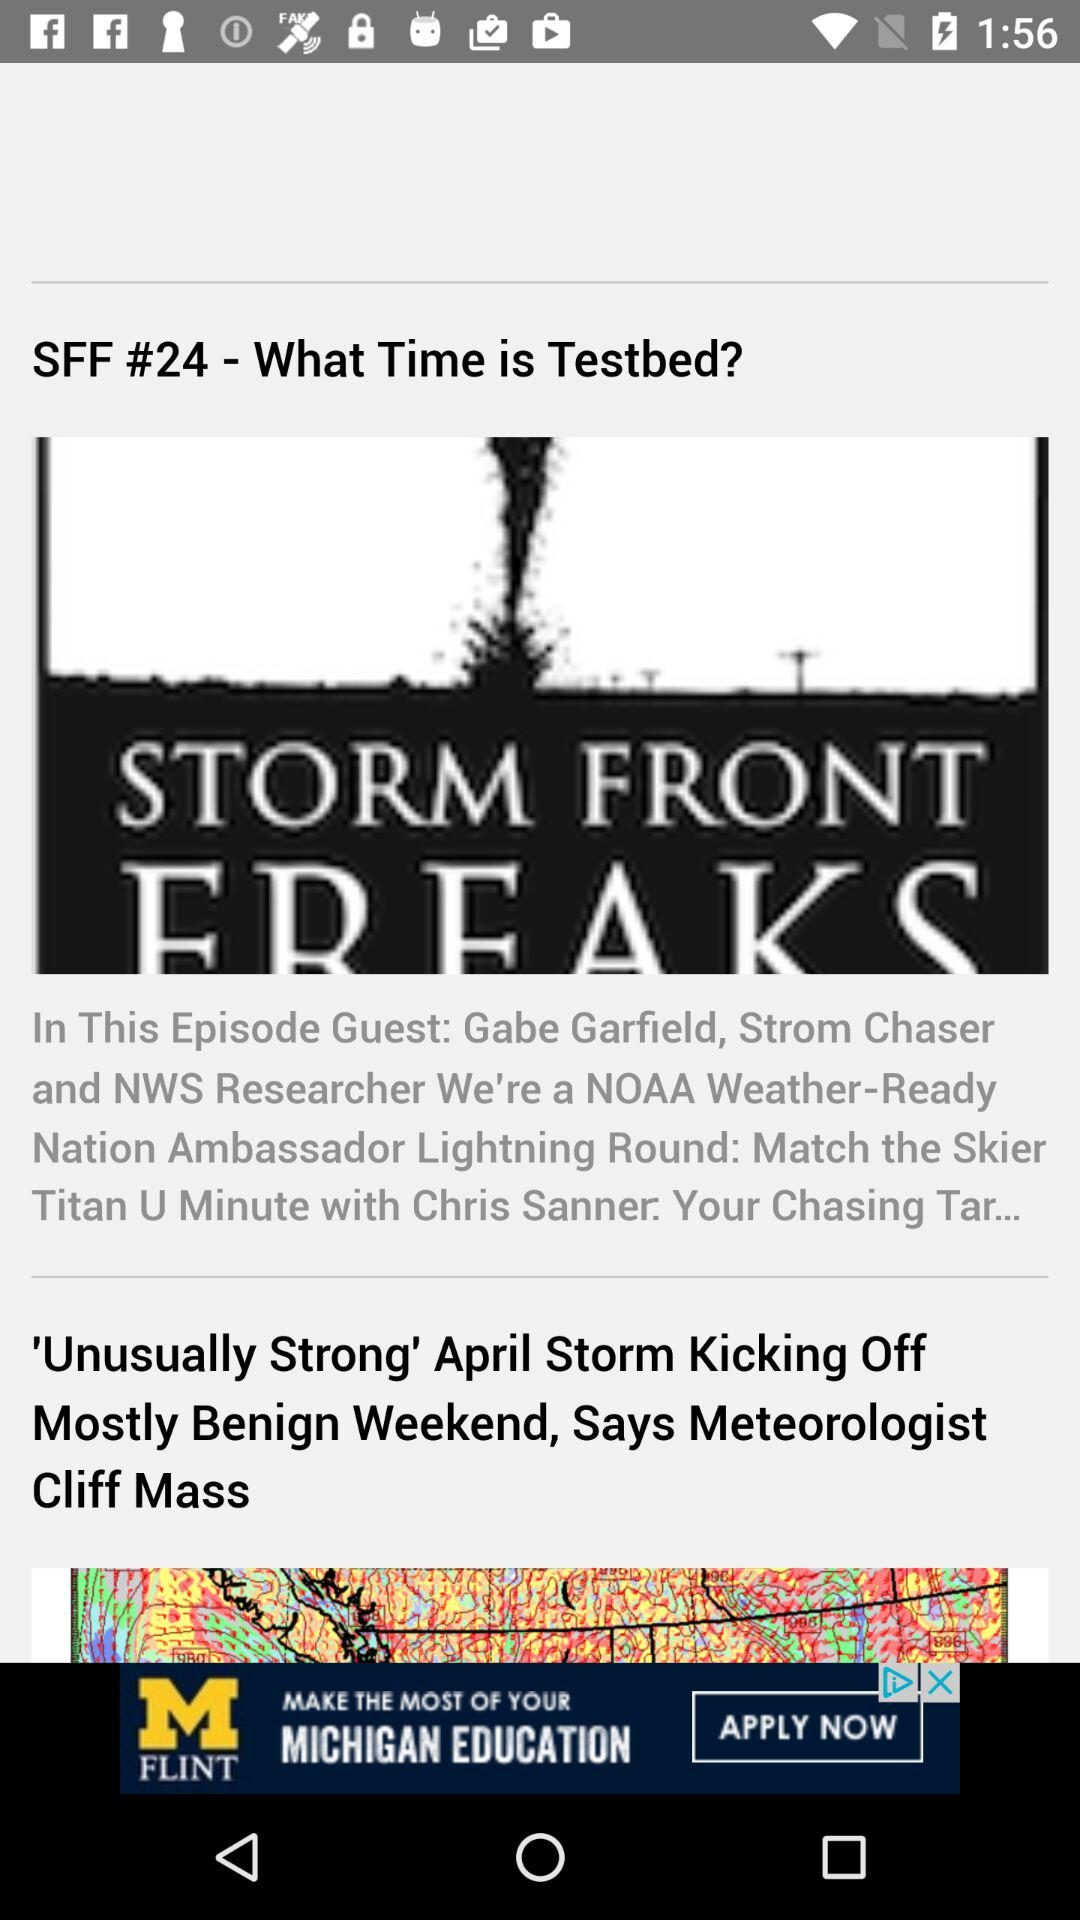What is the title of "SFF #24"? The title is "What Time is Testbed?". 